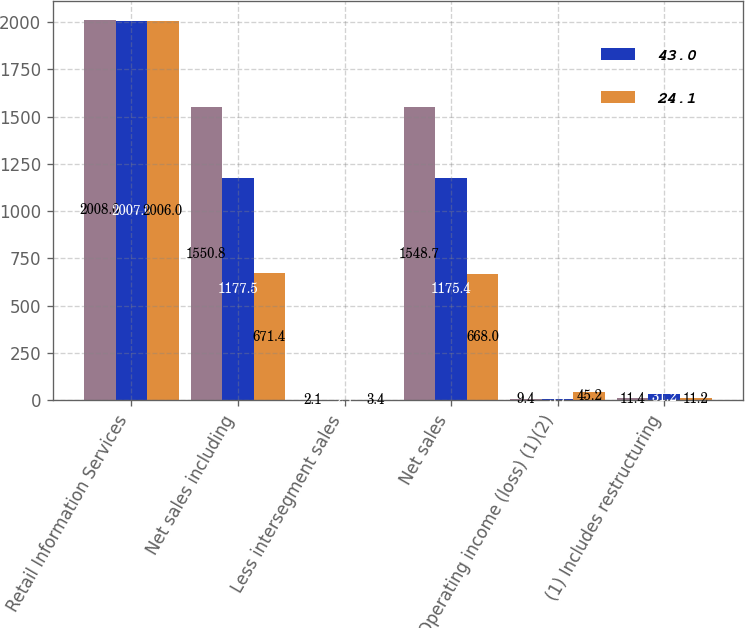<chart> <loc_0><loc_0><loc_500><loc_500><stacked_bar_chart><ecel><fcel>Retail Information Services<fcel>Net sales including<fcel>Less intersegment sales<fcel>Net sales<fcel>Operating income (loss) (1)(2)<fcel>(1) Includes restructuring<nl><fcel>nan<fcel>2008<fcel>1550.8<fcel>2.1<fcel>1548.7<fcel>9.4<fcel>11.4<nl><fcel>43<fcel>2007<fcel>1177.5<fcel>2.1<fcel>1175.4<fcel>5.7<fcel>31.2<nl><fcel>24.1<fcel>2006<fcel>671.4<fcel>3.4<fcel>668<fcel>45.2<fcel>11.2<nl></chart> 